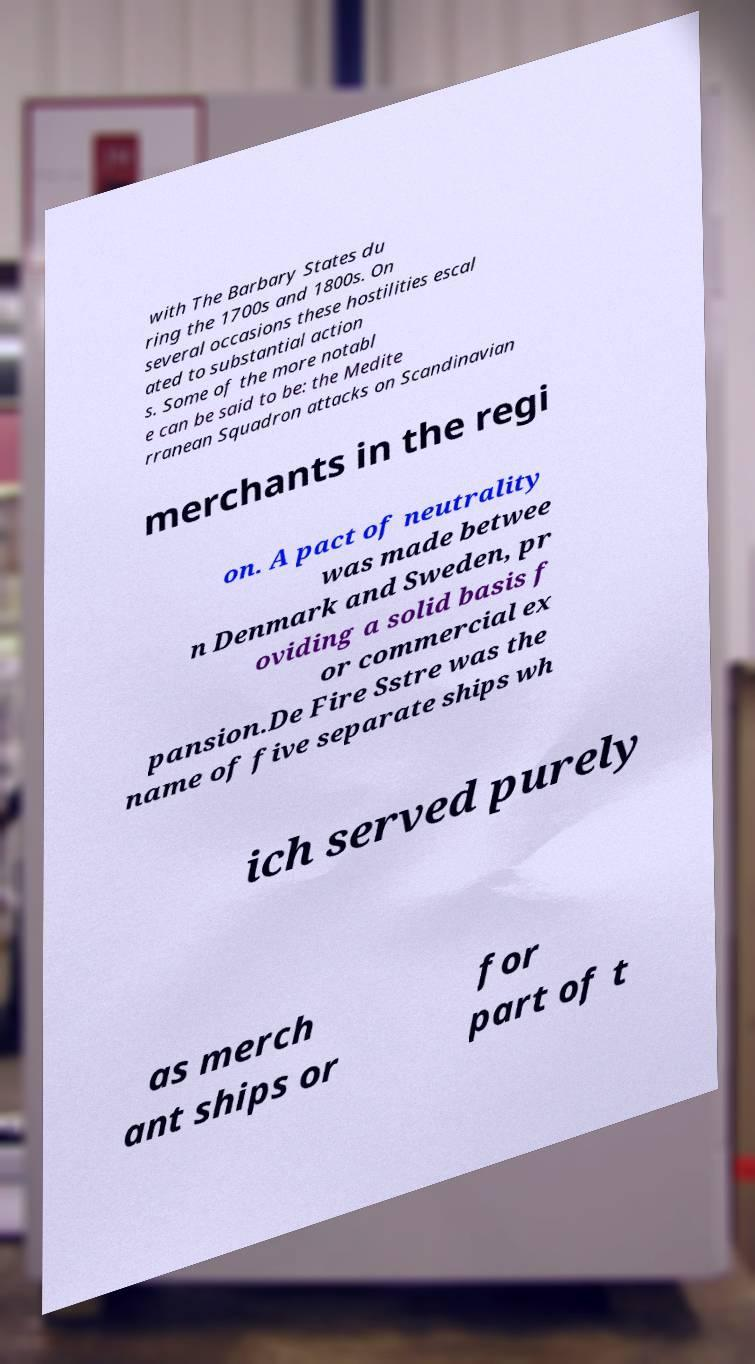I need the written content from this picture converted into text. Can you do that? with The Barbary States du ring the 1700s and 1800s. On several occasions these hostilities escal ated to substantial action s. Some of the more notabl e can be said to be: the Medite rranean Squadron attacks on Scandinavian merchants in the regi on. A pact of neutrality was made betwee n Denmark and Sweden, pr oviding a solid basis f or commercial ex pansion.De Fire Sstre was the name of five separate ships wh ich served purely as merch ant ships or for part of t 